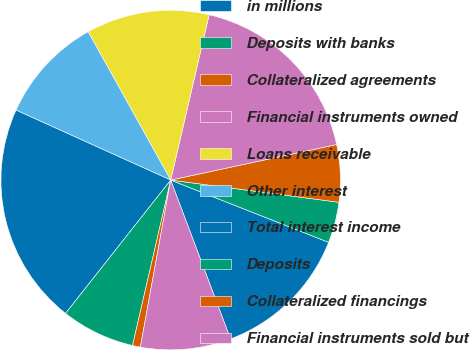Convert chart to OTSL. <chart><loc_0><loc_0><loc_500><loc_500><pie_chart><fcel>in millions<fcel>Deposits with banks<fcel>Collateralized agreements<fcel>Financial instruments owned<fcel>Loans receivable<fcel>Other interest<fcel>Total interest income<fcel>Deposits<fcel>Collateralized financings<fcel>Financial instruments sold but<nl><fcel>13.29%<fcel>3.89%<fcel>5.45%<fcel>18.0%<fcel>11.72%<fcel>10.16%<fcel>21.13%<fcel>7.02%<fcel>0.75%<fcel>8.59%<nl></chart> 